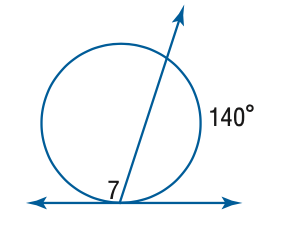Question: Find the measure of \angle 7.
Choices:
A. 70
B. 110
C. 140
D. 220
Answer with the letter. Answer: B 